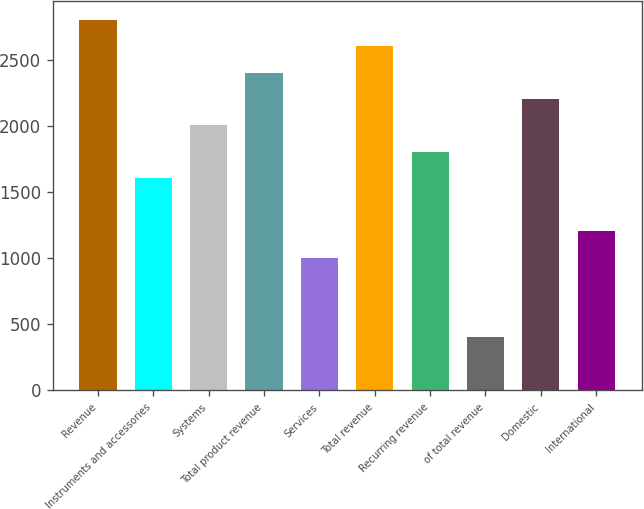<chart> <loc_0><loc_0><loc_500><loc_500><bar_chart><fcel>Revenue<fcel>Instruments and accessories<fcel>Systems<fcel>Total product revenue<fcel>Services<fcel>Total revenue<fcel>Recurring revenue<fcel>of total revenue<fcel>Domestic<fcel>International<nl><fcel>2807.4<fcel>1606.8<fcel>2007<fcel>2407.2<fcel>1006.5<fcel>2607.3<fcel>1806.9<fcel>406.2<fcel>2207.1<fcel>1206.6<nl></chart> 